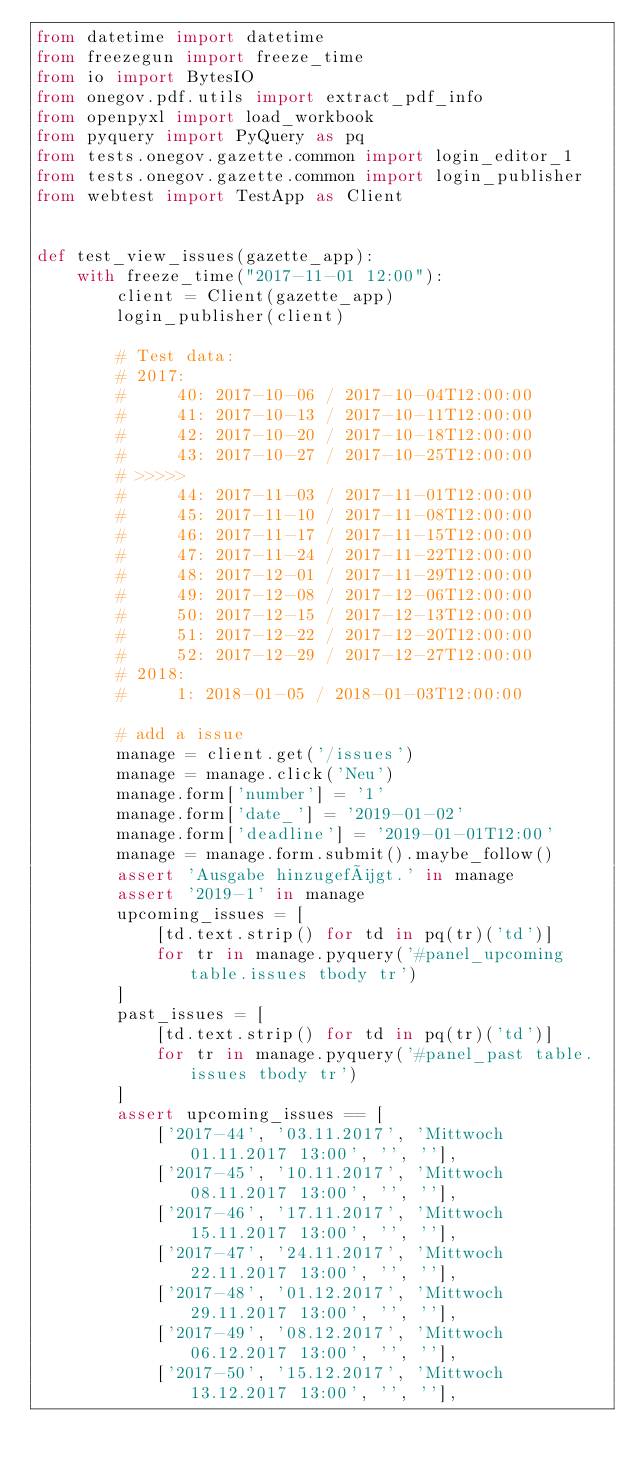Convert code to text. <code><loc_0><loc_0><loc_500><loc_500><_Python_>from datetime import datetime
from freezegun import freeze_time
from io import BytesIO
from onegov.pdf.utils import extract_pdf_info
from openpyxl import load_workbook
from pyquery import PyQuery as pq
from tests.onegov.gazette.common import login_editor_1
from tests.onegov.gazette.common import login_publisher
from webtest import TestApp as Client


def test_view_issues(gazette_app):
    with freeze_time("2017-11-01 12:00"):
        client = Client(gazette_app)
        login_publisher(client)

        # Test data:
        # 2017:
        #     40: 2017-10-06 / 2017-10-04T12:00:00
        #     41: 2017-10-13 / 2017-10-11T12:00:00
        #     42: 2017-10-20 / 2017-10-18T12:00:00
        #     43: 2017-10-27 / 2017-10-25T12:00:00
        # >>>>>
        #     44: 2017-11-03 / 2017-11-01T12:00:00
        #     45: 2017-11-10 / 2017-11-08T12:00:00
        #     46: 2017-11-17 / 2017-11-15T12:00:00
        #     47: 2017-11-24 / 2017-11-22T12:00:00
        #     48: 2017-12-01 / 2017-11-29T12:00:00
        #     49: 2017-12-08 / 2017-12-06T12:00:00
        #     50: 2017-12-15 / 2017-12-13T12:00:00
        #     51: 2017-12-22 / 2017-12-20T12:00:00
        #     52: 2017-12-29 / 2017-12-27T12:00:00
        # 2018:
        #     1: 2018-01-05 / 2018-01-03T12:00:00

        # add a issue
        manage = client.get('/issues')
        manage = manage.click('Neu')
        manage.form['number'] = '1'
        manage.form['date_'] = '2019-01-02'
        manage.form['deadline'] = '2019-01-01T12:00'
        manage = manage.form.submit().maybe_follow()
        assert 'Ausgabe hinzugefügt.' in manage
        assert '2019-1' in manage
        upcoming_issues = [
            [td.text.strip() for td in pq(tr)('td')]
            for tr in manage.pyquery('#panel_upcoming table.issues tbody tr')
        ]
        past_issues = [
            [td.text.strip() for td in pq(tr)('td')]
            for tr in manage.pyquery('#panel_past table.issues tbody tr')
        ]
        assert upcoming_issues == [
            ['2017-44', '03.11.2017', 'Mittwoch 01.11.2017 13:00', '', ''],
            ['2017-45', '10.11.2017', 'Mittwoch 08.11.2017 13:00', '', ''],
            ['2017-46', '17.11.2017', 'Mittwoch 15.11.2017 13:00', '', ''],
            ['2017-47', '24.11.2017', 'Mittwoch 22.11.2017 13:00', '', ''],
            ['2017-48', '01.12.2017', 'Mittwoch 29.11.2017 13:00', '', ''],
            ['2017-49', '08.12.2017', 'Mittwoch 06.12.2017 13:00', '', ''],
            ['2017-50', '15.12.2017', 'Mittwoch 13.12.2017 13:00', '', ''],</code> 